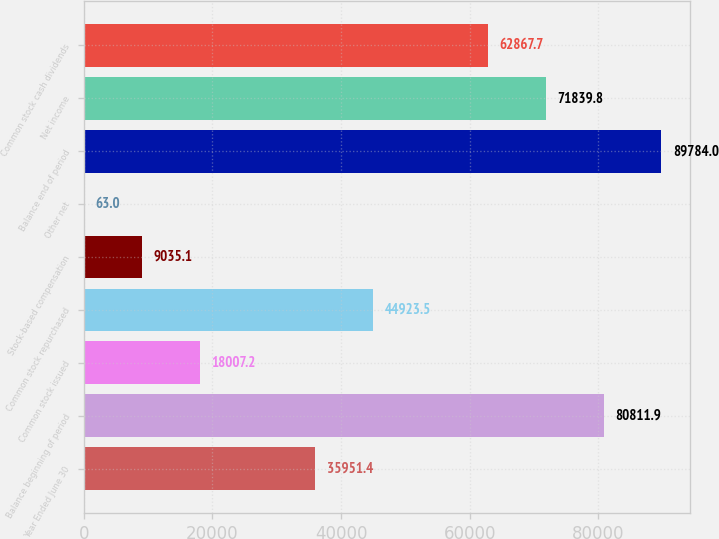<chart> <loc_0><loc_0><loc_500><loc_500><bar_chart><fcel>Year Ended June 30<fcel>Balance beginning of period<fcel>Common stock issued<fcel>Common stock repurchased<fcel>Stock-based compensation<fcel>Other net<fcel>Balance end of period<fcel>Net income<fcel>Common stock cash dividends<nl><fcel>35951.4<fcel>80811.9<fcel>18007.2<fcel>44923.5<fcel>9035.1<fcel>63<fcel>89784<fcel>71839.8<fcel>62867.7<nl></chart> 